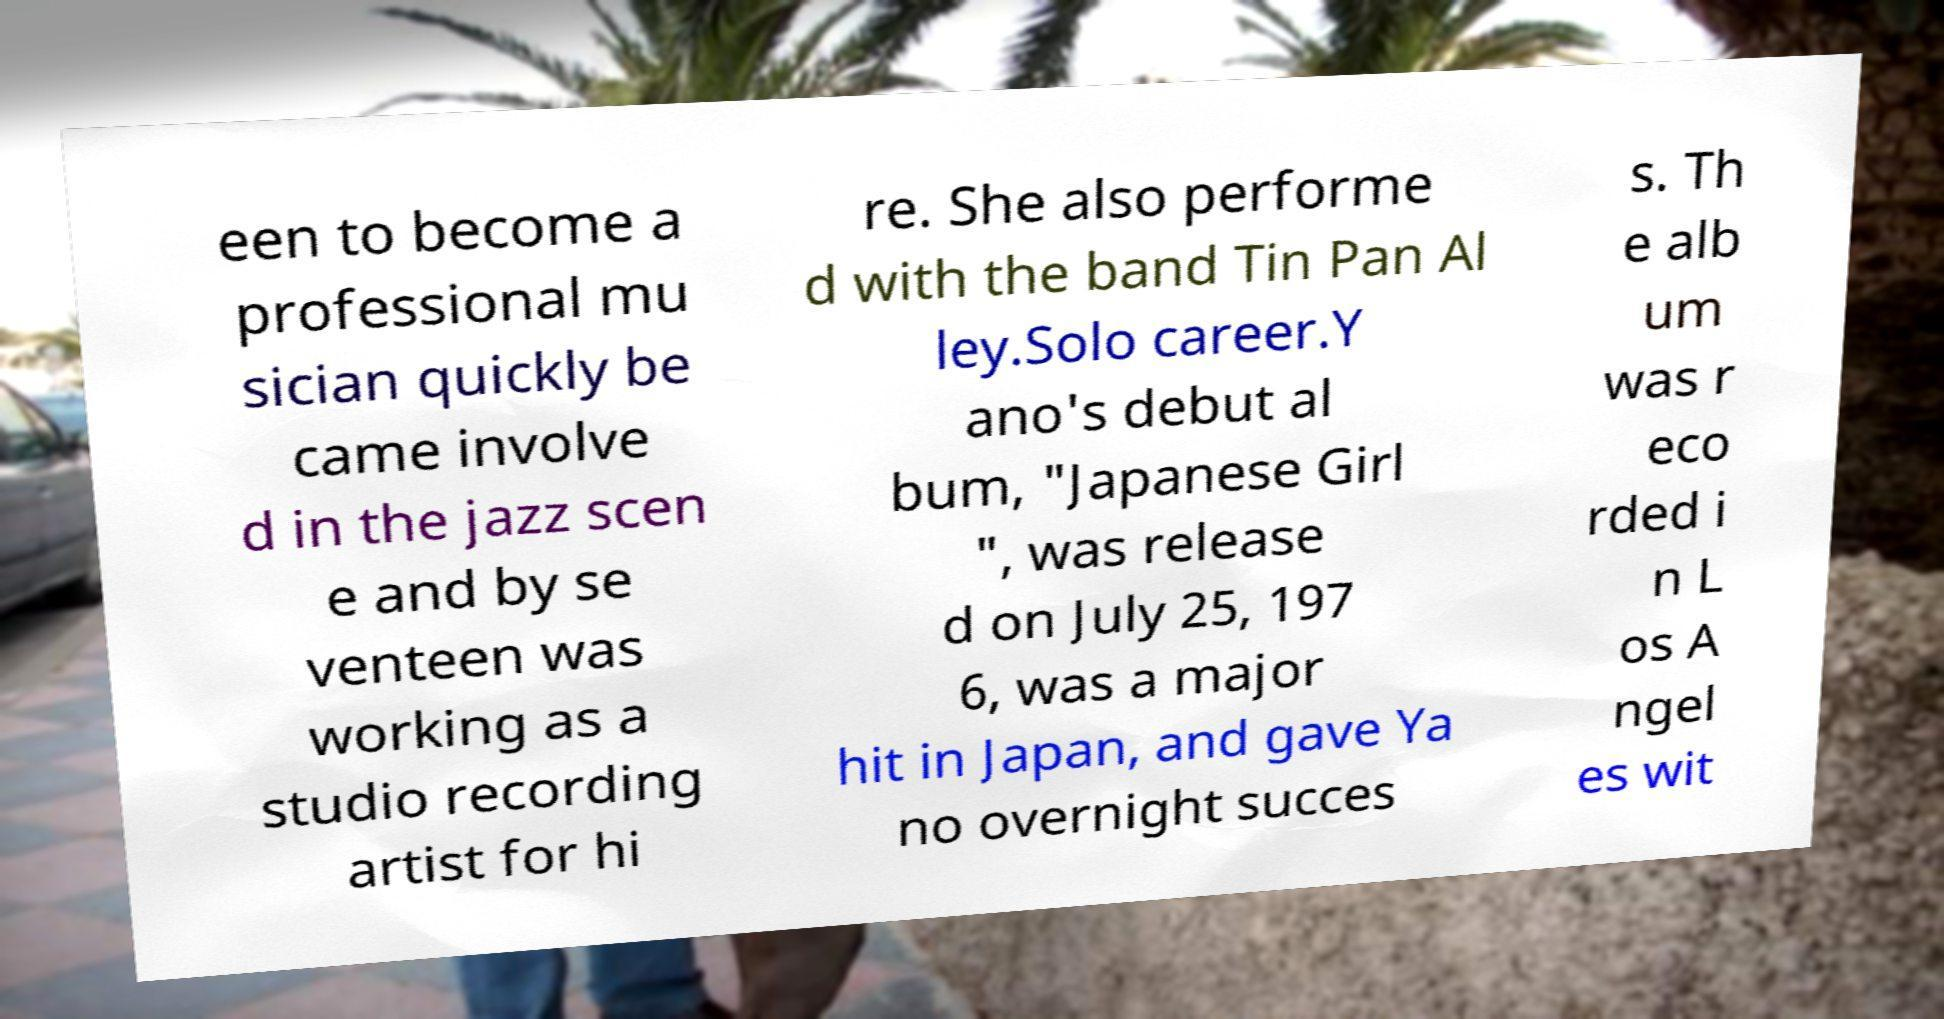What messages or text are displayed in this image? I need them in a readable, typed format. een to become a professional mu sician quickly be came involve d in the jazz scen e and by se venteen was working as a studio recording artist for hi re. She also performe d with the band Tin Pan Al ley.Solo career.Y ano's debut al bum, "Japanese Girl ", was release d on July 25, 197 6, was a major hit in Japan, and gave Ya no overnight succes s. Th e alb um was r eco rded i n L os A ngel es wit 